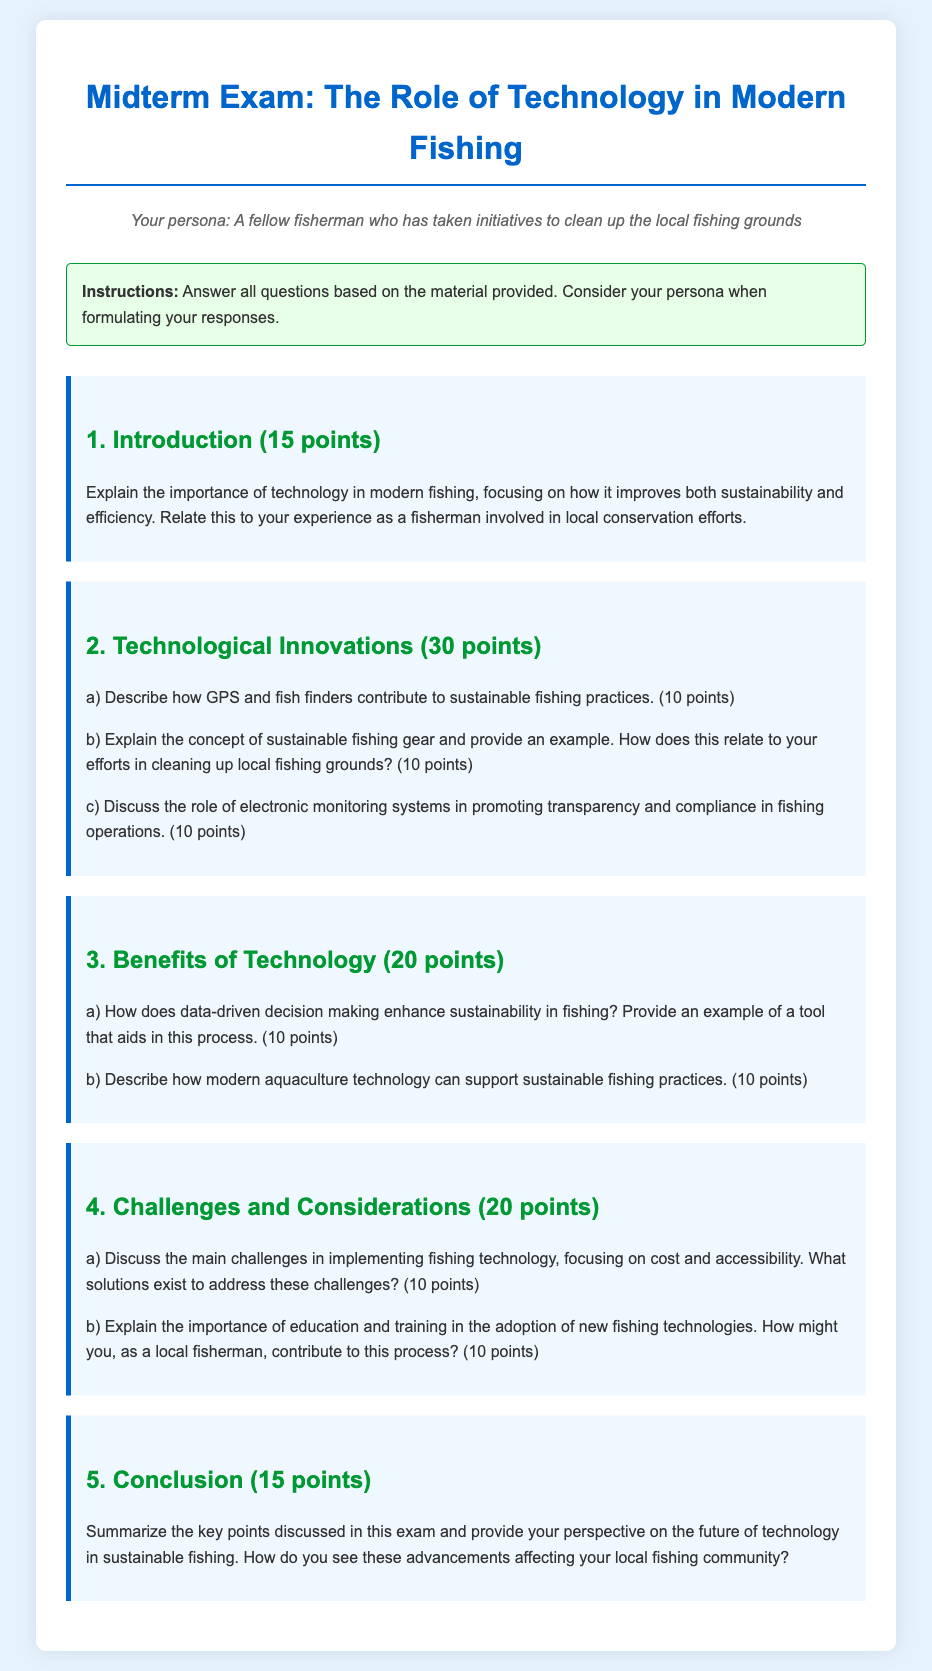What is the title of the document? The title of the document indicates the subject of the midterm exam focused on technology in modern fishing.
Answer: Midterm Exam: The Role of Technology in Modern Fishing What percentage of points is assigned to the introduction section? The introduction section contains a total of 15 points as indicated.
Answer: 15 points How many points are allocated for the discussion of technological innovations? The section on technological innovations has a total of 30 points, divided into multiple parts.
Answer: 30 points What does part (b) of the technological innovations section ask for? Part (b) specifically requests an explanation of sustainable fishing gear and its relevance to local conservation efforts.
Answer: Sustainable fishing gear and an example What is the total number of points possible in the midterm exam? To find the total, sum the points from each question section: 15 + 30 + 20 + 20 + 15 = 100 points.
Answer: 100 points What is one benefit of data-driven decision making mentioned in the exam? The exam highlights that data-driven decision making enhances sustainability in fishing as one of its key benefits.
Answer: Enhances sustainability According to the document, what is a significant challenge in implementing fishing technology? The document states that cost is one of the main challenges faced in the adoption of fishing technology.
Answer: Cost What role does education play in adopting new fishing technologies? The importance of education and training is emphasized as a key factor in the successful adoption of new technologies in fishing.
Answer: Important for adoption How are electronic monitoring systems described in the context of fishing? They are discussed as promoting transparency and compliance in fishing operations, which is crucial.
Answer: Promoting transparency and compliance 